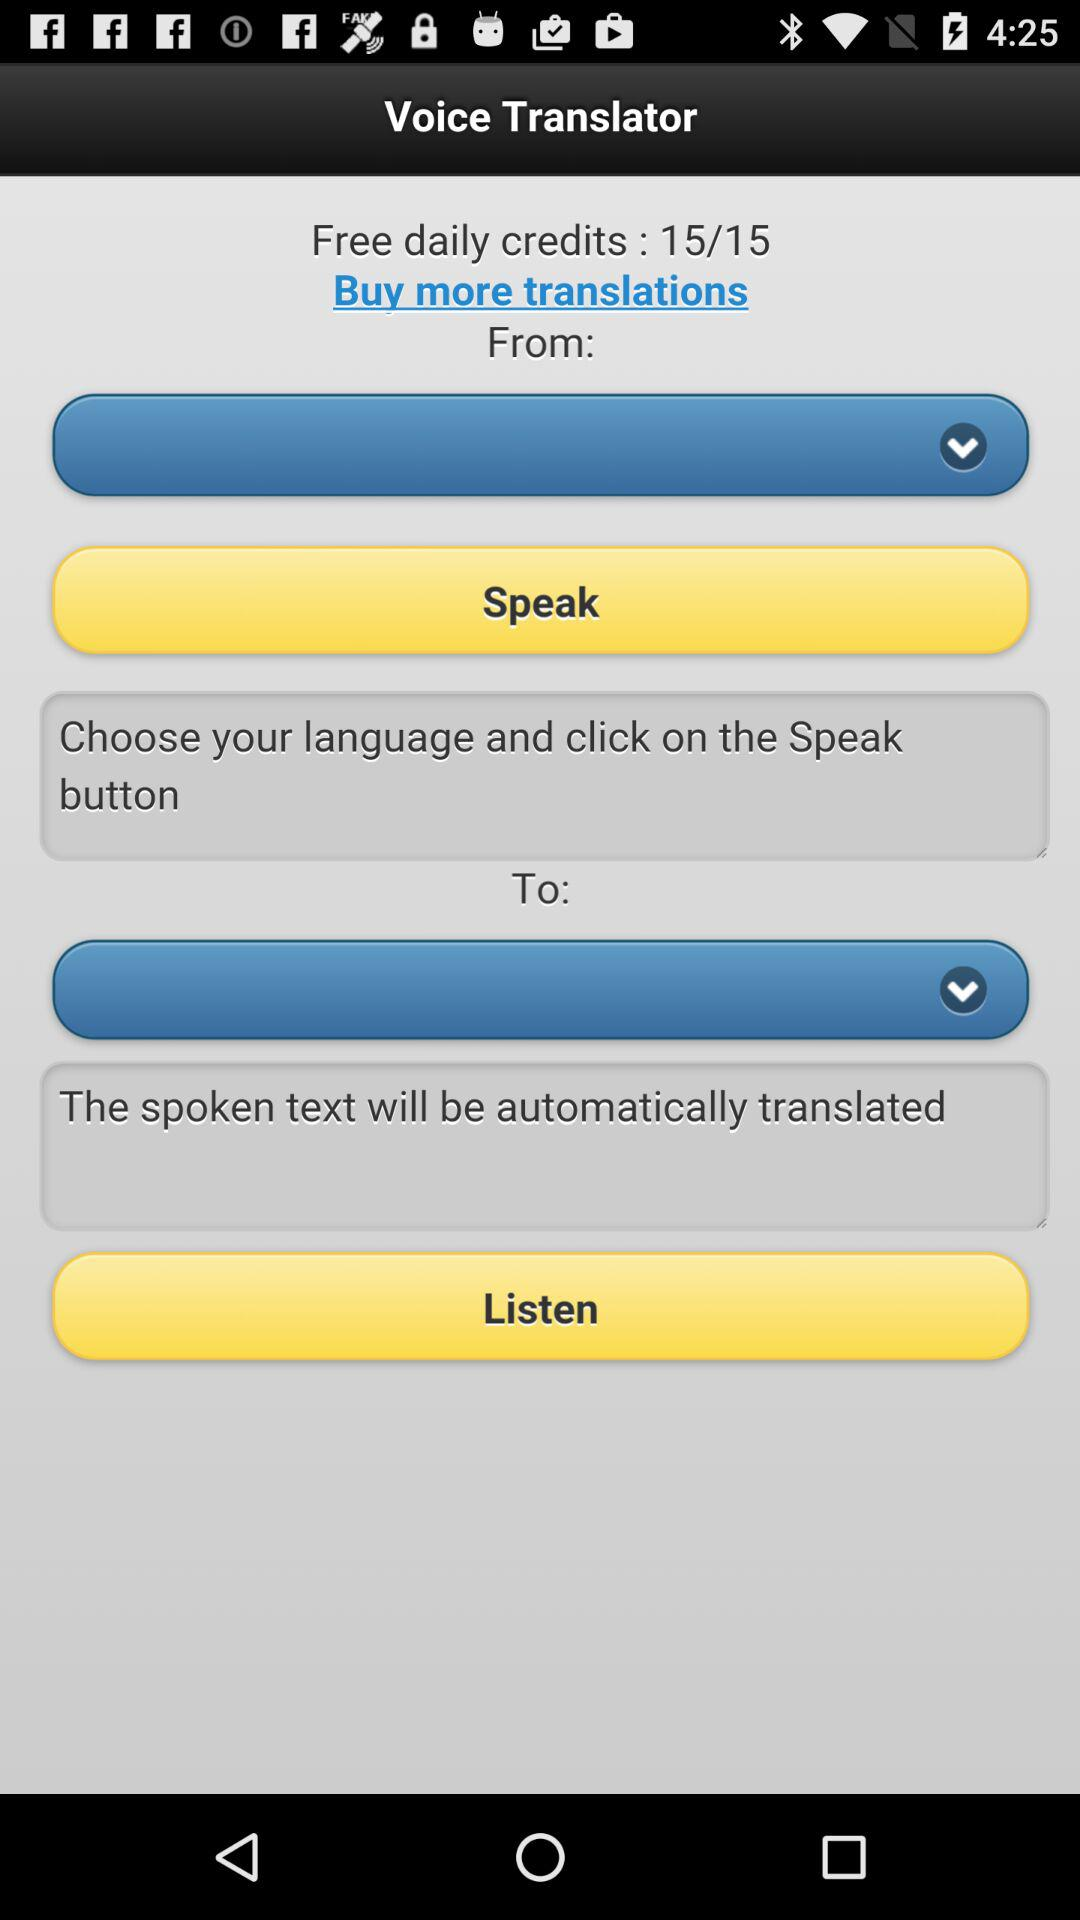How many more credits do I need to buy to have 30 credits?
Answer the question using a single word or phrase. 15 